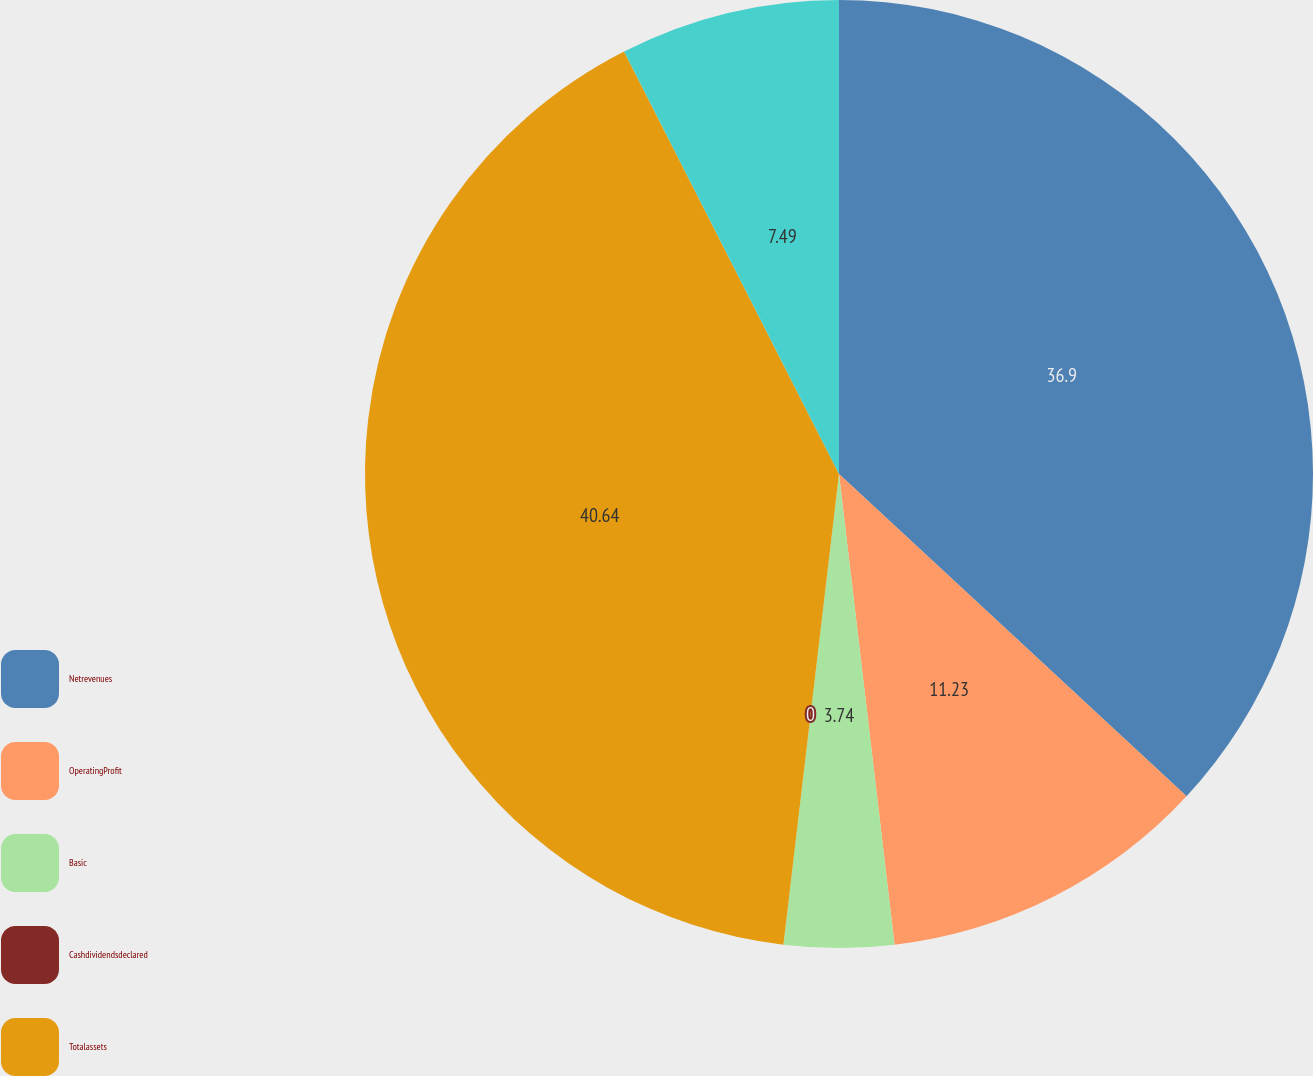<chart> <loc_0><loc_0><loc_500><loc_500><pie_chart><fcel>Netrevenues<fcel>OperatingProfit<fcel>Basic<fcel>Cashdividendsdeclared<fcel>Totalassets<fcel>Unnamed: 5<nl><fcel>36.9%<fcel>11.23%<fcel>3.74%<fcel>0.0%<fcel>40.64%<fcel>7.49%<nl></chart> 